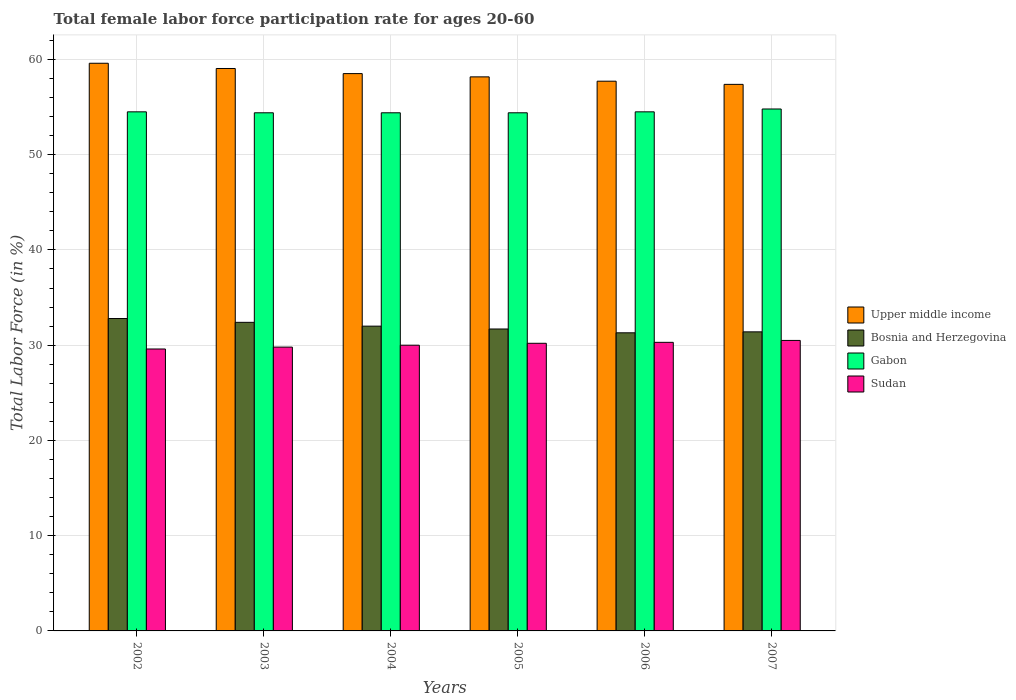How many different coloured bars are there?
Your response must be concise. 4. How many groups of bars are there?
Provide a succinct answer. 6. Are the number of bars per tick equal to the number of legend labels?
Your answer should be very brief. Yes. Are the number of bars on each tick of the X-axis equal?
Offer a terse response. Yes. How many bars are there on the 2nd tick from the right?
Offer a very short reply. 4. What is the label of the 2nd group of bars from the left?
Offer a terse response. 2003. What is the female labor force participation rate in Upper middle income in 2002?
Ensure brevity in your answer.  59.6. Across all years, what is the maximum female labor force participation rate in Upper middle income?
Your answer should be very brief. 59.6. Across all years, what is the minimum female labor force participation rate in Bosnia and Herzegovina?
Keep it short and to the point. 31.3. In which year was the female labor force participation rate in Bosnia and Herzegovina maximum?
Make the answer very short. 2002. What is the total female labor force participation rate in Sudan in the graph?
Provide a succinct answer. 180.4. What is the difference between the female labor force participation rate in Upper middle income in 2003 and that in 2005?
Ensure brevity in your answer.  0.88. What is the difference between the female labor force participation rate in Bosnia and Herzegovina in 2007 and the female labor force participation rate in Sudan in 2003?
Give a very brief answer. 1.6. What is the average female labor force participation rate in Upper middle income per year?
Ensure brevity in your answer.  58.41. In the year 2003, what is the difference between the female labor force participation rate in Bosnia and Herzegovina and female labor force participation rate in Gabon?
Provide a succinct answer. -22. In how many years, is the female labor force participation rate in Bosnia and Herzegovina greater than 42 %?
Your answer should be compact. 0. What is the ratio of the female labor force participation rate in Gabon in 2002 to that in 2007?
Offer a terse response. 0.99. Is the female labor force participation rate in Bosnia and Herzegovina in 2002 less than that in 2004?
Your answer should be compact. No. What is the difference between the highest and the second highest female labor force participation rate in Upper middle income?
Keep it short and to the point. 0.55. What is the difference between the highest and the lowest female labor force participation rate in Upper middle income?
Provide a succinct answer. 2.22. In how many years, is the female labor force participation rate in Upper middle income greater than the average female labor force participation rate in Upper middle income taken over all years?
Your answer should be very brief. 3. What does the 4th bar from the left in 2003 represents?
Your response must be concise. Sudan. What does the 4th bar from the right in 2006 represents?
Keep it short and to the point. Upper middle income. How many years are there in the graph?
Make the answer very short. 6. What is the difference between two consecutive major ticks on the Y-axis?
Make the answer very short. 10. Does the graph contain any zero values?
Offer a terse response. No. Where does the legend appear in the graph?
Make the answer very short. Center right. How are the legend labels stacked?
Provide a short and direct response. Vertical. What is the title of the graph?
Your answer should be very brief. Total female labor force participation rate for ages 20-60. What is the Total Labor Force (in %) of Upper middle income in 2002?
Keep it short and to the point. 59.6. What is the Total Labor Force (in %) of Bosnia and Herzegovina in 2002?
Offer a terse response. 32.8. What is the Total Labor Force (in %) of Gabon in 2002?
Offer a terse response. 54.5. What is the Total Labor Force (in %) in Sudan in 2002?
Provide a short and direct response. 29.6. What is the Total Labor Force (in %) of Upper middle income in 2003?
Your response must be concise. 59.05. What is the Total Labor Force (in %) of Bosnia and Herzegovina in 2003?
Offer a very short reply. 32.4. What is the Total Labor Force (in %) of Gabon in 2003?
Ensure brevity in your answer.  54.4. What is the Total Labor Force (in %) of Sudan in 2003?
Provide a succinct answer. 29.8. What is the Total Labor Force (in %) in Upper middle income in 2004?
Offer a very short reply. 58.51. What is the Total Labor Force (in %) of Gabon in 2004?
Provide a short and direct response. 54.4. What is the Total Labor Force (in %) in Sudan in 2004?
Offer a terse response. 30. What is the Total Labor Force (in %) of Upper middle income in 2005?
Offer a terse response. 58.17. What is the Total Labor Force (in %) in Bosnia and Herzegovina in 2005?
Give a very brief answer. 31.7. What is the Total Labor Force (in %) in Gabon in 2005?
Your answer should be compact. 54.4. What is the Total Labor Force (in %) in Sudan in 2005?
Ensure brevity in your answer.  30.2. What is the Total Labor Force (in %) of Upper middle income in 2006?
Make the answer very short. 57.72. What is the Total Labor Force (in %) of Bosnia and Herzegovina in 2006?
Your answer should be very brief. 31.3. What is the Total Labor Force (in %) of Gabon in 2006?
Ensure brevity in your answer.  54.5. What is the Total Labor Force (in %) of Sudan in 2006?
Offer a terse response. 30.3. What is the Total Labor Force (in %) of Upper middle income in 2007?
Your answer should be compact. 57.38. What is the Total Labor Force (in %) of Bosnia and Herzegovina in 2007?
Give a very brief answer. 31.4. What is the Total Labor Force (in %) of Gabon in 2007?
Provide a succinct answer. 54.8. What is the Total Labor Force (in %) of Sudan in 2007?
Ensure brevity in your answer.  30.5. Across all years, what is the maximum Total Labor Force (in %) in Upper middle income?
Make the answer very short. 59.6. Across all years, what is the maximum Total Labor Force (in %) in Bosnia and Herzegovina?
Offer a very short reply. 32.8. Across all years, what is the maximum Total Labor Force (in %) of Gabon?
Give a very brief answer. 54.8. Across all years, what is the maximum Total Labor Force (in %) in Sudan?
Your response must be concise. 30.5. Across all years, what is the minimum Total Labor Force (in %) in Upper middle income?
Make the answer very short. 57.38. Across all years, what is the minimum Total Labor Force (in %) of Bosnia and Herzegovina?
Make the answer very short. 31.3. Across all years, what is the minimum Total Labor Force (in %) in Gabon?
Provide a short and direct response. 54.4. Across all years, what is the minimum Total Labor Force (in %) in Sudan?
Ensure brevity in your answer.  29.6. What is the total Total Labor Force (in %) in Upper middle income in the graph?
Provide a short and direct response. 350.44. What is the total Total Labor Force (in %) of Bosnia and Herzegovina in the graph?
Your answer should be very brief. 191.6. What is the total Total Labor Force (in %) in Gabon in the graph?
Your answer should be very brief. 327. What is the total Total Labor Force (in %) of Sudan in the graph?
Ensure brevity in your answer.  180.4. What is the difference between the Total Labor Force (in %) in Upper middle income in 2002 and that in 2003?
Your response must be concise. 0.55. What is the difference between the Total Labor Force (in %) of Gabon in 2002 and that in 2003?
Offer a very short reply. 0.1. What is the difference between the Total Labor Force (in %) of Upper middle income in 2002 and that in 2004?
Your response must be concise. 1.09. What is the difference between the Total Labor Force (in %) in Bosnia and Herzegovina in 2002 and that in 2004?
Your answer should be compact. 0.8. What is the difference between the Total Labor Force (in %) of Gabon in 2002 and that in 2004?
Your response must be concise. 0.1. What is the difference between the Total Labor Force (in %) in Upper middle income in 2002 and that in 2005?
Provide a short and direct response. 1.43. What is the difference between the Total Labor Force (in %) of Bosnia and Herzegovina in 2002 and that in 2005?
Your response must be concise. 1.1. What is the difference between the Total Labor Force (in %) of Upper middle income in 2002 and that in 2006?
Your response must be concise. 1.88. What is the difference between the Total Labor Force (in %) of Bosnia and Herzegovina in 2002 and that in 2006?
Make the answer very short. 1.5. What is the difference between the Total Labor Force (in %) of Upper middle income in 2002 and that in 2007?
Make the answer very short. 2.22. What is the difference between the Total Labor Force (in %) in Bosnia and Herzegovina in 2002 and that in 2007?
Make the answer very short. 1.4. What is the difference between the Total Labor Force (in %) in Upper middle income in 2003 and that in 2004?
Provide a succinct answer. 0.54. What is the difference between the Total Labor Force (in %) in Sudan in 2003 and that in 2004?
Give a very brief answer. -0.2. What is the difference between the Total Labor Force (in %) of Upper middle income in 2003 and that in 2005?
Offer a very short reply. 0.88. What is the difference between the Total Labor Force (in %) of Bosnia and Herzegovina in 2003 and that in 2005?
Provide a succinct answer. 0.7. What is the difference between the Total Labor Force (in %) in Upper middle income in 2003 and that in 2006?
Keep it short and to the point. 1.33. What is the difference between the Total Labor Force (in %) of Bosnia and Herzegovina in 2003 and that in 2006?
Your response must be concise. 1.1. What is the difference between the Total Labor Force (in %) of Gabon in 2003 and that in 2006?
Your answer should be very brief. -0.1. What is the difference between the Total Labor Force (in %) of Sudan in 2003 and that in 2006?
Your answer should be very brief. -0.5. What is the difference between the Total Labor Force (in %) in Upper middle income in 2003 and that in 2007?
Your answer should be very brief. 1.67. What is the difference between the Total Labor Force (in %) in Bosnia and Herzegovina in 2003 and that in 2007?
Keep it short and to the point. 1. What is the difference between the Total Labor Force (in %) in Sudan in 2003 and that in 2007?
Provide a short and direct response. -0.7. What is the difference between the Total Labor Force (in %) of Upper middle income in 2004 and that in 2005?
Provide a short and direct response. 0.34. What is the difference between the Total Labor Force (in %) of Upper middle income in 2004 and that in 2006?
Ensure brevity in your answer.  0.8. What is the difference between the Total Labor Force (in %) in Gabon in 2004 and that in 2006?
Offer a terse response. -0.1. What is the difference between the Total Labor Force (in %) in Upper middle income in 2004 and that in 2007?
Give a very brief answer. 1.13. What is the difference between the Total Labor Force (in %) in Bosnia and Herzegovina in 2004 and that in 2007?
Your answer should be compact. 0.6. What is the difference between the Total Labor Force (in %) of Gabon in 2004 and that in 2007?
Provide a succinct answer. -0.4. What is the difference between the Total Labor Force (in %) of Sudan in 2004 and that in 2007?
Provide a succinct answer. -0.5. What is the difference between the Total Labor Force (in %) in Upper middle income in 2005 and that in 2006?
Offer a very short reply. 0.45. What is the difference between the Total Labor Force (in %) of Sudan in 2005 and that in 2006?
Provide a succinct answer. -0.1. What is the difference between the Total Labor Force (in %) of Upper middle income in 2005 and that in 2007?
Your answer should be compact. 0.79. What is the difference between the Total Labor Force (in %) in Bosnia and Herzegovina in 2005 and that in 2007?
Make the answer very short. 0.3. What is the difference between the Total Labor Force (in %) in Gabon in 2005 and that in 2007?
Ensure brevity in your answer.  -0.4. What is the difference between the Total Labor Force (in %) of Sudan in 2005 and that in 2007?
Your answer should be compact. -0.3. What is the difference between the Total Labor Force (in %) of Upper middle income in 2006 and that in 2007?
Make the answer very short. 0.33. What is the difference between the Total Labor Force (in %) in Bosnia and Herzegovina in 2006 and that in 2007?
Your answer should be very brief. -0.1. What is the difference between the Total Labor Force (in %) of Gabon in 2006 and that in 2007?
Your answer should be very brief. -0.3. What is the difference between the Total Labor Force (in %) in Upper middle income in 2002 and the Total Labor Force (in %) in Bosnia and Herzegovina in 2003?
Offer a terse response. 27.2. What is the difference between the Total Labor Force (in %) in Upper middle income in 2002 and the Total Labor Force (in %) in Gabon in 2003?
Give a very brief answer. 5.2. What is the difference between the Total Labor Force (in %) in Upper middle income in 2002 and the Total Labor Force (in %) in Sudan in 2003?
Offer a very short reply. 29.8. What is the difference between the Total Labor Force (in %) in Bosnia and Herzegovina in 2002 and the Total Labor Force (in %) in Gabon in 2003?
Keep it short and to the point. -21.6. What is the difference between the Total Labor Force (in %) of Bosnia and Herzegovina in 2002 and the Total Labor Force (in %) of Sudan in 2003?
Your response must be concise. 3. What is the difference between the Total Labor Force (in %) in Gabon in 2002 and the Total Labor Force (in %) in Sudan in 2003?
Make the answer very short. 24.7. What is the difference between the Total Labor Force (in %) in Upper middle income in 2002 and the Total Labor Force (in %) in Bosnia and Herzegovina in 2004?
Provide a short and direct response. 27.6. What is the difference between the Total Labor Force (in %) in Upper middle income in 2002 and the Total Labor Force (in %) in Gabon in 2004?
Give a very brief answer. 5.2. What is the difference between the Total Labor Force (in %) in Upper middle income in 2002 and the Total Labor Force (in %) in Sudan in 2004?
Provide a short and direct response. 29.6. What is the difference between the Total Labor Force (in %) in Bosnia and Herzegovina in 2002 and the Total Labor Force (in %) in Gabon in 2004?
Ensure brevity in your answer.  -21.6. What is the difference between the Total Labor Force (in %) of Upper middle income in 2002 and the Total Labor Force (in %) of Bosnia and Herzegovina in 2005?
Provide a succinct answer. 27.9. What is the difference between the Total Labor Force (in %) in Upper middle income in 2002 and the Total Labor Force (in %) in Gabon in 2005?
Offer a terse response. 5.2. What is the difference between the Total Labor Force (in %) in Upper middle income in 2002 and the Total Labor Force (in %) in Sudan in 2005?
Provide a succinct answer. 29.4. What is the difference between the Total Labor Force (in %) of Bosnia and Herzegovina in 2002 and the Total Labor Force (in %) of Gabon in 2005?
Give a very brief answer. -21.6. What is the difference between the Total Labor Force (in %) in Bosnia and Herzegovina in 2002 and the Total Labor Force (in %) in Sudan in 2005?
Your answer should be compact. 2.6. What is the difference between the Total Labor Force (in %) of Gabon in 2002 and the Total Labor Force (in %) of Sudan in 2005?
Provide a succinct answer. 24.3. What is the difference between the Total Labor Force (in %) of Upper middle income in 2002 and the Total Labor Force (in %) of Bosnia and Herzegovina in 2006?
Your answer should be very brief. 28.3. What is the difference between the Total Labor Force (in %) in Upper middle income in 2002 and the Total Labor Force (in %) in Gabon in 2006?
Make the answer very short. 5.1. What is the difference between the Total Labor Force (in %) in Upper middle income in 2002 and the Total Labor Force (in %) in Sudan in 2006?
Ensure brevity in your answer.  29.3. What is the difference between the Total Labor Force (in %) of Bosnia and Herzegovina in 2002 and the Total Labor Force (in %) of Gabon in 2006?
Keep it short and to the point. -21.7. What is the difference between the Total Labor Force (in %) of Gabon in 2002 and the Total Labor Force (in %) of Sudan in 2006?
Keep it short and to the point. 24.2. What is the difference between the Total Labor Force (in %) in Upper middle income in 2002 and the Total Labor Force (in %) in Bosnia and Herzegovina in 2007?
Keep it short and to the point. 28.2. What is the difference between the Total Labor Force (in %) of Upper middle income in 2002 and the Total Labor Force (in %) of Gabon in 2007?
Keep it short and to the point. 4.8. What is the difference between the Total Labor Force (in %) of Upper middle income in 2002 and the Total Labor Force (in %) of Sudan in 2007?
Offer a very short reply. 29.1. What is the difference between the Total Labor Force (in %) in Upper middle income in 2003 and the Total Labor Force (in %) in Bosnia and Herzegovina in 2004?
Offer a terse response. 27.05. What is the difference between the Total Labor Force (in %) of Upper middle income in 2003 and the Total Labor Force (in %) of Gabon in 2004?
Provide a succinct answer. 4.65. What is the difference between the Total Labor Force (in %) of Upper middle income in 2003 and the Total Labor Force (in %) of Sudan in 2004?
Offer a very short reply. 29.05. What is the difference between the Total Labor Force (in %) in Gabon in 2003 and the Total Labor Force (in %) in Sudan in 2004?
Your answer should be compact. 24.4. What is the difference between the Total Labor Force (in %) in Upper middle income in 2003 and the Total Labor Force (in %) in Bosnia and Herzegovina in 2005?
Ensure brevity in your answer.  27.35. What is the difference between the Total Labor Force (in %) of Upper middle income in 2003 and the Total Labor Force (in %) of Gabon in 2005?
Offer a very short reply. 4.65. What is the difference between the Total Labor Force (in %) in Upper middle income in 2003 and the Total Labor Force (in %) in Sudan in 2005?
Give a very brief answer. 28.85. What is the difference between the Total Labor Force (in %) of Bosnia and Herzegovina in 2003 and the Total Labor Force (in %) of Sudan in 2005?
Provide a succinct answer. 2.2. What is the difference between the Total Labor Force (in %) of Gabon in 2003 and the Total Labor Force (in %) of Sudan in 2005?
Make the answer very short. 24.2. What is the difference between the Total Labor Force (in %) of Upper middle income in 2003 and the Total Labor Force (in %) of Bosnia and Herzegovina in 2006?
Give a very brief answer. 27.75. What is the difference between the Total Labor Force (in %) in Upper middle income in 2003 and the Total Labor Force (in %) in Gabon in 2006?
Offer a very short reply. 4.55. What is the difference between the Total Labor Force (in %) in Upper middle income in 2003 and the Total Labor Force (in %) in Sudan in 2006?
Your answer should be very brief. 28.75. What is the difference between the Total Labor Force (in %) of Bosnia and Herzegovina in 2003 and the Total Labor Force (in %) of Gabon in 2006?
Ensure brevity in your answer.  -22.1. What is the difference between the Total Labor Force (in %) of Bosnia and Herzegovina in 2003 and the Total Labor Force (in %) of Sudan in 2006?
Offer a very short reply. 2.1. What is the difference between the Total Labor Force (in %) in Gabon in 2003 and the Total Labor Force (in %) in Sudan in 2006?
Your response must be concise. 24.1. What is the difference between the Total Labor Force (in %) of Upper middle income in 2003 and the Total Labor Force (in %) of Bosnia and Herzegovina in 2007?
Ensure brevity in your answer.  27.65. What is the difference between the Total Labor Force (in %) in Upper middle income in 2003 and the Total Labor Force (in %) in Gabon in 2007?
Provide a short and direct response. 4.25. What is the difference between the Total Labor Force (in %) of Upper middle income in 2003 and the Total Labor Force (in %) of Sudan in 2007?
Make the answer very short. 28.55. What is the difference between the Total Labor Force (in %) of Bosnia and Herzegovina in 2003 and the Total Labor Force (in %) of Gabon in 2007?
Give a very brief answer. -22.4. What is the difference between the Total Labor Force (in %) of Gabon in 2003 and the Total Labor Force (in %) of Sudan in 2007?
Keep it short and to the point. 23.9. What is the difference between the Total Labor Force (in %) of Upper middle income in 2004 and the Total Labor Force (in %) of Bosnia and Herzegovina in 2005?
Ensure brevity in your answer.  26.81. What is the difference between the Total Labor Force (in %) in Upper middle income in 2004 and the Total Labor Force (in %) in Gabon in 2005?
Offer a very short reply. 4.11. What is the difference between the Total Labor Force (in %) of Upper middle income in 2004 and the Total Labor Force (in %) of Sudan in 2005?
Give a very brief answer. 28.31. What is the difference between the Total Labor Force (in %) in Bosnia and Herzegovina in 2004 and the Total Labor Force (in %) in Gabon in 2005?
Provide a succinct answer. -22.4. What is the difference between the Total Labor Force (in %) in Bosnia and Herzegovina in 2004 and the Total Labor Force (in %) in Sudan in 2005?
Give a very brief answer. 1.8. What is the difference between the Total Labor Force (in %) in Gabon in 2004 and the Total Labor Force (in %) in Sudan in 2005?
Provide a succinct answer. 24.2. What is the difference between the Total Labor Force (in %) of Upper middle income in 2004 and the Total Labor Force (in %) of Bosnia and Herzegovina in 2006?
Keep it short and to the point. 27.21. What is the difference between the Total Labor Force (in %) in Upper middle income in 2004 and the Total Labor Force (in %) in Gabon in 2006?
Your response must be concise. 4.01. What is the difference between the Total Labor Force (in %) of Upper middle income in 2004 and the Total Labor Force (in %) of Sudan in 2006?
Offer a terse response. 28.21. What is the difference between the Total Labor Force (in %) in Bosnia and Herzegovina in 2004 and the Total Labor Force (in %) in Gabon in 2006?
Provide a short and direct response. -22.5. What is the difference between the Total Labor Force (in %) of Bosnia and Herzegovina in 2004 and the Total Labor Force (in %) of Sudan in 2006?
Your response must be concise. 1.7. What is the difference between the Total Labor Force (in %) of Gabon in 2004 and the Total Labor Force (in %) of Sudan in 2006?
Keep it short and to the point. 24.1. What is the difference between the Total Labor Force (in %) in Upper middle income in 2004 and the Total Labor Force (in %) in Bosnia and Herzegovina in 2007?
Your answer should be very brief. 27.11. What is the difference between the Total Labor Force (in %) of Upper middle income in 2004 and the Total Labor Force (in %) of Gabon in 2007?
Make the answer very short. 3.71. What is the difference between the Total Labor Force (in %) of Upper middle income in 2004 and the Total Labor Force (in %) of Sudan in 2007?
Keep it short and to the point. 28.01. What is the difference between the Total Labor Force (in %) in Bosnia and Herzegovina in 2004 and the Total Labor Force (in %) in Gabon in 2007?
Provide a short and direct response. -22.8. What is the difference between the Total Labor Force (in %) of Bosnia and Herzegovina in 2004 and the Total Labor Force (in %) of Sudan in 2007?
Make the answer very short. 1.5. What is the difference between the Total Labor Force (in %) in Gabon in 2004 and the Total Labor Force (in %) in Sudan in 2007?
Your answer should be very brief. 23.9. What is the difference between the Total Labor Force (in %) of Upper middle income in 2005 and the Total Labor Force (in %) of Bosnia and Herzegovina in 2006?
Offer a terse response. 26.87. What is the difference between the Total Labor Force (in %) of Upper middle income in 2005 and the Total Labor Force (in %) of Gabon in 2006?
Offer a terse response. 3.67. What is the difference between the Total Labor Force (in %) in Upper middle income in 2005 and the Total Labor Force (in %) in Sudan in 2006?
Keep it short and to the point. 27.87. What is the difference between the Total Labor Force (in %) in Bosnia and Herzegovina in 2005 and the Total Labor Force (in %) in Gabon in 2006?
Make the answer very short. -22.8. What is the difference between the Total Labor Force (in %) in Gabon in 2005 and the Total Labor Force (in %) in Sudan in 2006?
Give a very brief answer. 24.1. What is the difference between the Total Labor Force (in %) in Upper middle income in 2005 and the Total Labor Force (in %) in Bosnia and Herzegovina in 2007?
Provide a short and direct response. 26.77. What is the difference between the Total Labor Force (in %) of Upper middle income in 2005 and the Total Labor Force (in %) of Gabon in 2007?
Your response must be concise. 3.37. What is the difference between the Total Labor Force (in %) in Upper middle income in 2005 and the Total Labor Force (in %) in Sudan in 2007?
Offer a terse response. 27.67. What is the difference between the Total Labor Force (in %) of Bosnia and Herzegovina in 2005 and the Total Labor Force (in %) of Gabon in 2007?
Your response must be concise. -23.1. What is the difference between the Total Labor Force (in %) of Bosnia and Herzegovina in 2005 and the Total Labor Force (in %) of Sudan in 2007?
Your answer should be compact. 1.2. What is the difference between the Total Labor Force (in %) of Gabon in 2005 and the Total Labor Force (in %) of Sudan in 2007?
Make the answer very short. 23.9. What is the difference between the Total Labor Force (in %) of Upper middle income in 2006 and the Total Labor Force (in %) of Bosnia and Herzegovina in 2007?
Your answer should be compact. 26.32. What is the difference between the Total Labor Force (in %) of Upper middle income in 2006 and the Total Labor Force (in %) of Gabon in 2007?
Your response must be concise. 2.92. What is the difference between the Total Labor Force (in %) of Upper middle income in 2006 and the Total Labor Force (in %) of Sudan in 2007?
Offer a very short reply. 27.22. What is the difference between the Total Labor Force (in %) in Bosnia and Herzegovina in 2006 and the Total Labor Force (in %) in Gabon in 2007?
Keep it short and to the point. -23.5. What is the difference between the Total Labor Force (in %) of Gabon in 2006 and the Total Labor Force (in %) of Sudan in 2007?
Your response must be concise. 24. What is the average Total Labor Force (in %) in Upper middle income per year?
Provide a short and direct response. 58.41. What is the average Total Labor Force (in %) in Bosnia and Herzegovina per year?
Your answer should be very brief. 31.93. What is the average Total Labor Force (in %) of Gabon per year?
Your answer should be compact. 54.5. What is the average Total Labor Force (in %) in Sudan per year?
Your response must be concise. 30.07. In the year 2002, what is the difference between the Total Labor Force (in %) of Upper middle income and Total Labor Force (in %) of Bosnia and Herzegovina?
Your answer should be very brief. 26.8. In the year 2002, what is the difference between the Total Labor Force (in %) of Upper middle income and Total Labor Force (in %) of Gabon?
Make the answer very short. 5.1. In the year 2002, what is the difference between the Total Labor Force (in %) of Upper middle income and Total Labor Force (in %) of Sudan?
Provide a succinct answer. 30. In the year 2002, what is the difference between the Total Labor Force (in %) in Bosnia and Herzegovina and Total Labor Force (in %) in Gabon?
Offer a terse response. -21.7. In the year 2002, what is the difference between the Total Labor Force (in %) of Gabon and Total Labor Force (in %) of Sudan?
Give a very brief answer. 24.9. In the year 2003, what is the difference between the Total Labor Force (in %) in Upper middle income and Total Labor Force (in %) in Bosnia and Herzegovina?
Provide a succinct answer. 26.65. In the year 2003, what is the difference between the Total Labor Force (in %) of Upper middle income and Total Labor Force (in %) of Gabon?
Make the answer very short. 4.65. In the year 2003, what is the difference between the Total Labor Force (in %) in Upper middle income and Total Labor Force (in %) in Sudan?
Keep it short and to the point. 29.25. In the year 2003, what is the difference between the Total Labor Force (in %) in Bosnia and Herzegovina and Total Labor Force (in %) in Sudan?
Provide a short and direct response. 2.6. In the year 2003, what is the difference between the Total Labor Force (in %) of Gabon and Total Labor Force (in %) of Sudan?
Provide a succinct answer. 24.6. In the year 2004, what is the difference between the Total Labor Force (in %) in Upper middle income and Total Labor Force (in %) in Bosnia and Herzegovina?
Make the answer very short. 26.51. In the year 2004, what is the difference between the Total Labor Force (in %) in Upper middle income and Total Labor Force (in %) in Gabon?
Provide a short and direct response. 4.11. In the year 2004, what is the difference between the Total Labor Force (in %) in Upper middle income and Total Labor Force (in %) in Sudan?
Your answer should be compact. 28.51. In the year 2004, what is the difference between the Total Labor Force (in %) in Bosnia and Herzegovina and Total Labor Force (in %) in Gabon?
Provide a short and direct response. -22.4. In the year 2004, what is the difference between the Total Labor Force (in %) of Bosnia and Herzegovina and Total Labor Force (in %) of Sudan?
Provide a short and direct response. 2. In the year 2004, what is the difference between the Total Labor Force (in %) in Gabon and Total Labor Force (in %) in Sudan?
Offer a very short reply. 24.4. In the year 2005, what is the difference between the Total Labor Force (in %) in Upper middle income and Total Labor Force (in %) in Bosnia and Herzegovina?
Your answer should be compact. 26.47. In the year 2005, what is the difference between the Total Labor Force (in %) of Upper middle income and Total Labor Force (in %) of Gabon?
Your answer should be compact. 3.77. In the year 2005, what is the difference between the Total Labor Force (in %) of Upper middle income and Total Labor Force (in %) of Sudan?
Your answer should be compact. 27.97. In the year 2005, what is the difference between the Total Labor Force (in %) of Bosnia and Herzegovina and Total Labor Force (in %) of Gabon?
Offer a terse response. -22.7. In the year 2005, what is the difference between the Total Labor Force (in %) of Gabon and Total Labor Force (in %) of Sudan?
Provide a succinct answer. 24.2. In the year 2006, what is the difference between the Total Labor Force (in %) in Upper middle income and Total Labor Force (in %) in Bosnia and Herzegovina?
Your response must be concise. 26.42. In the year 2006, what is the difference between the Total Labor Force (in %) in Upper middle income and Total Labor Force (in %) in Gabon?
Provide a short and direct response. 3.22. In the year 2006, what is the difference between the Total Labor Force (in %) of Upper middle income and Total Labor Force (in %) of Sudan?
Give a very brief answer. 27.42. In the year 2006, what is the difference between the Total Labor Force (in %) in Bosnia and Herzegovina and Total Labor Force (in %) in Gabon?
Provide a short and direct response. -23.2. In the year 2006, what is the difference between the Total Labor Force (in %) of Gabon and Total Labor Force (in %) of Sudan?
Your answer should be very brief. 24.2. In the year 2007, what is the difference between the Total Labor Force (in %) in Upper middle income and Total Labor Force (in %) in Bosnia and Herzegovina?
Give a very brief answer. 25.98. In the year 2007, what is the difference between the Total Labor Force (in %) of Upper middle income and Total Labor Force (in %) of Gabon?
Offer a terse response. 2.58. In the year 2007, what is the difference between the Total Labor Force (in %) in Upper middle income and Total Labor Force (in %) in Sudan?
Make the answer very short. 26.88. In the year 2007, what is the difference between the Total Labor Force (in %) in Bosnia and Herzegovina and Total Labor Force (in %) in Gabon?
Give a very brief answer. -23.4. In the year 2007, what is the difference between the Total Labor Force (in %) of Gabon and Total Labor Force (in %) of Sudan?
Your answer should be compact. 24.3. What is the ratio of the Total Labor Force (in %) of Upper middle income in 2002 to that in 2003?
Your answer should be very brief. 1.01. What is the ratio of the Total Labor Force (in %) in Bosnia and Herzegovina in 2002 to that in 2003?
Ensure brevity in your answer.  1.01. What is the ratio of the Total Labor Force (in %) in Sudan in 2002 to that in 2003?
Make the answer very short. 0.99. What is the ratio of the Total Labor Force (in %) in Upper middle income in 2002 to that in 2004?
Provide a succinct answer. 1.02. What is the ratio of the Total Labor Force (in %) in Sudan in 2002 to that in 2004?
Offer a very short reply. 0.99. What is the ratio of the Total Labor Force (in %) in Upper middle income in 2002 to that in 2005?
Provide a succinct answer. 1.02. What is the ratio of the Total Labor Force (in %) of Bosnia and Herzegovina in 2002 to that in 2005?
Ensure brevity in your answer.  1.03. What is the ratio of the Total Labor Force (in %) in Gabon in 2002 to that in 2005?
Offer a very short reply. 1. What is the ratio of the Total Labor Force (in %) in Sudan in 2002 to that in 2005?
Offer a very short reply. 0.98. What is the ratio of the Total Labor Force (in %) of Upper middle income in 2002 to that in 2006?
Ensure brevity in your answer.  1.03. What is the ratio of the Total Labor Force (in %) of Bosnia and Herzegovina in 2002 to that in 2006?
Keep it short and to the point. 1.05. What is the ratio of the Total Labor Force (in %) of Sudan in 2002 to that in 2006?
Offer a terse response. 0.98. What is the ratio of the Total Labor Force (in %) of Upper middle income in 2002 to that in 2007?
Offer a very short reply. 1.04. What is the ratio of the Total Labor Force (in %) of Bosnia and Herzegovina in 2002 to that in 2007?
Your answer should be compact. 1.04. What is the ratio of the Total Labor Force (in %) of Gabon in 2002 to that in 2007?
Provide a succinct answer. 0.99. What is the ratio of the Total Labor Force (in %) of Sudan in 2002 to that in 2007?
Provide a succinct answer. 0.97. What is the ratio of the Total Labor Force (in %) in Upper middle income in 2003 to that in 2004?
Provide a succinct answer. 1.01. What is the ratio of the Total Labor Force (in %) of Bosnia and Herzegovina in 2003 to that in 2004?
Your answer should be compact. 1.01. What is the ratio of the Total Labor Force (in %) of Upper middle income in 2003 to that in 2005?
Your answer should be compact. 1.02. What is the ratio of the Total Labor Force (in %) in Bosnia and Herzegovina in 2003 to that in 2005?
Your answer should be very brief. 1.02. What is the ratio of the Total Labor Force (in %) in Gabon in 2003 to that in 2005?
Provide a short and direct response. 1. What is the ratio of the Total Labor Force (in %) of Upper middle income in 2003 to that in 2006?
Your answer should be very brief. 1.02. What is the ratio of the Total Labor Force (in %) in Bosnia and Herzegovina in 2003 to that in 2006?
Offer a very short reply. 1.04. What is the ratio of the Total Labor Force (in %) in Sudan in 2003 to that in 2006?
Keep it short and to the point. 0.98. What is the ratio of the Total Labor Force (in %) of Upper middle income in 2003 to that in 2007?
Ensure brevity in your answer.  1.03. What is the ratio of the Total Labor Force (in %) of Bosnia and Herzegovina in 2003 to that in 2007?
Give a very brief answer. 1.03. What is the ratio of the Total Labor Force (in %) in Gabon in 2003 to that in 2007?
Your response must be concise. 0.99. What is the ratio of the Total Labor Force (in %) of Upper middle income in 2004 to that in 2005?
Ensure brevity in your answer.  1.01. What is the ratio of the Total Labor Force (in %) of Bosnia and Herzegovina in 2004 to that in 2005?
Your answer should be very brief. 1.01. What is the ratio of the Total Labor Force (in %) of Upper middle income in 2004 to that in 2006?
Keep it short and to the point. 1.01. What is the ratio of the Total Labor Force (in %) of Bosnia and Herzegovina in 2004 to that in 2006?
Give a very brief answer. 1.02. What is the ratio of the Total Labor Force (in %) of Upper middle income in 2004 to that in 2007?
Give a very brief answer. 1.02. What is the ratio of the Total Labor Force (in %) in Bosnia and Herzegovina in 2004 to that in 2007?
Offer a terse response. 1.02. What is the ratio of the Total Labor Force (in %) of Sudan in 2004 to that in 2007?
Provide a short and direct response. 0.98. What is the ratio of the Total Labor Force (in %) in Upper middle income in 2005 to that in 2006?
Keep it short and to the point. 1.01. What is the ratio of the Total Labor Force (in %) in Bosnia and Herzegovina in 2005 to that in 2006?
Your answer should be compact. 1.01. What is the ratio of the Total Labor Force (in %) of Upper middle income in 2005 to that in 2007?
Offer a terse response. 1.01. What is the ratio of the Total Labor Force (in %) of Bosnia and Herzegovina in 2005 to that in 2007?
Give a very brief answer. 1.01. What is the ratio of the Total Labor Force (in %) in Sudan in 2005 to that in 2007?
Your response must be concise. 0.99. What is the ratio of the Total Labor Force (in %) in Upper middle income in 2006 to that in 2007?
Give a very brief answer. 1.01. What is the ratio of the Total Labor Force (in %) of Sudan in 2006 to that in 2007?
Ensure brevity in your answer.  0.99. What is the difference between the highest and the second highest Total Labor Force (in %) in Upper middle income?
Your response must be concise. 0.55. What is the difference between the highest and the lowest Total Labor Force (in %) of Upper middle income?
Your response must be concise. 2.22. What is the difference between the highest and the lowest Total Labor Force (in %) of Gabon?
Offer a very short reply. 0.4. What is the difference between the highest and the lowest Total Labor Force (in %) of Sudan?
Provide a succinct answer. 0.9. 